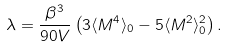<formula> <loc_0><loc_0><loc_500><loc_500>\lambda = \frac { \beta ^ { 3 } } { 9 0 V } \left ( 3 \langle { M ^ { 4 } } \rangle _ { 0 } - 5 \langle { M ^ { 2 } } \rangle _ { 0 } ^ { 2 } \right ) .</formula> 